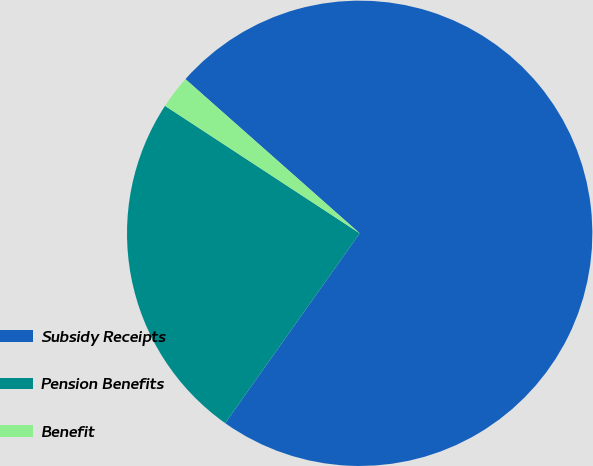Convert chart to OTSL. <chart><loc_0><loc_0><loc_500><loc_500><pie_chart><fcel>Subsidy Receipts<fcel>Pension Benefits<fcel>Benefit<nl><fcel>73.28%<fcel>24.42%<fcel>2.3%<nl></chart> 